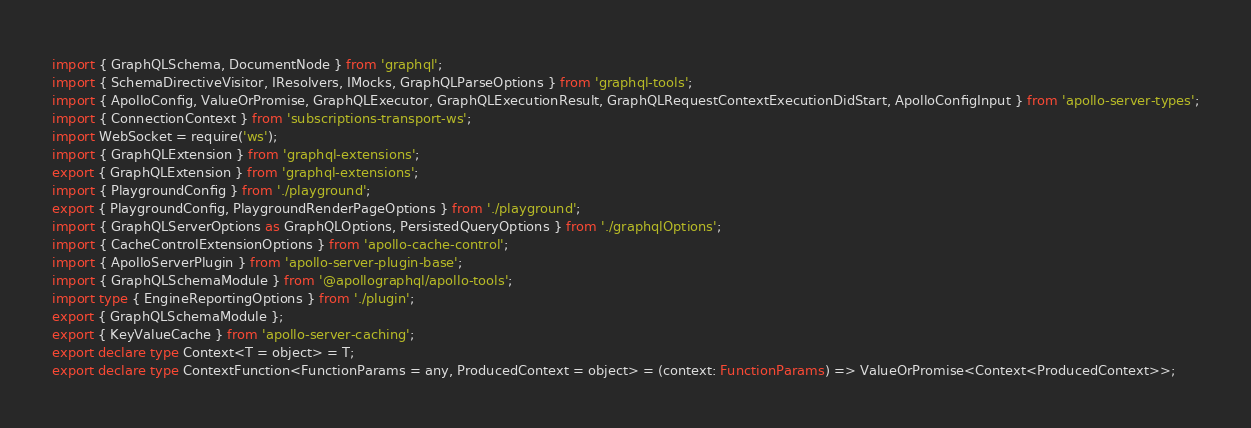Convert code to text. <code><loc_0><loc_0><loc_500><loc_500><_TypeScript_>import { GraphQLSchema, DocumentNode } from 'graphql';
import { SchemaDirectiveVisitor, IResolvers, IMocks, GraphQLParseOptions } from 'graphql-tools';
import { ApolloConfig, ValueOrPromise, GraphQLExecutor, GraphQLExecutionResult, GraphQLRequestContextExecutionDidStart, ApolloConfigInput } from 'apollo-server-types';
import { ConnectionContext } from 'subscriptions-transport-ws';
import WebSocket = require('ws');
import { GraphQLExtension } from 'graphql-extensions';
export { GraphQLExtension } from 'graphql-extensions';
import { PlaygroundConfig } from './playground';
export { PlaygroundConfig, PlaygroundRenderPageOptions } from './playground';
import { GraphQLServerOptions as GraphQLOptions, PersistedQueryOptions } from './graphqlOptions';
import { CacheControlExtensionOptions } from 'apollo-cache-control';
import { ApolloServerPlugin } from 'apollo-server-plugin-base';
import { GraphQLSchemaModule } from '@apollographql/apollo-tools';
import type { EngineReportingOptions } from './plugin';
export { GraphQLSchemaModule };
export { KeyValueCache } from 'apollo-server-caching';
export declare type Context<T = object> = T;
export declare type ContextFunction<FunctionParams = any, ProducedContext = object> = (context: FunctionParams) => ValueOrPromise<Context<ProducedContext>>;</code> 